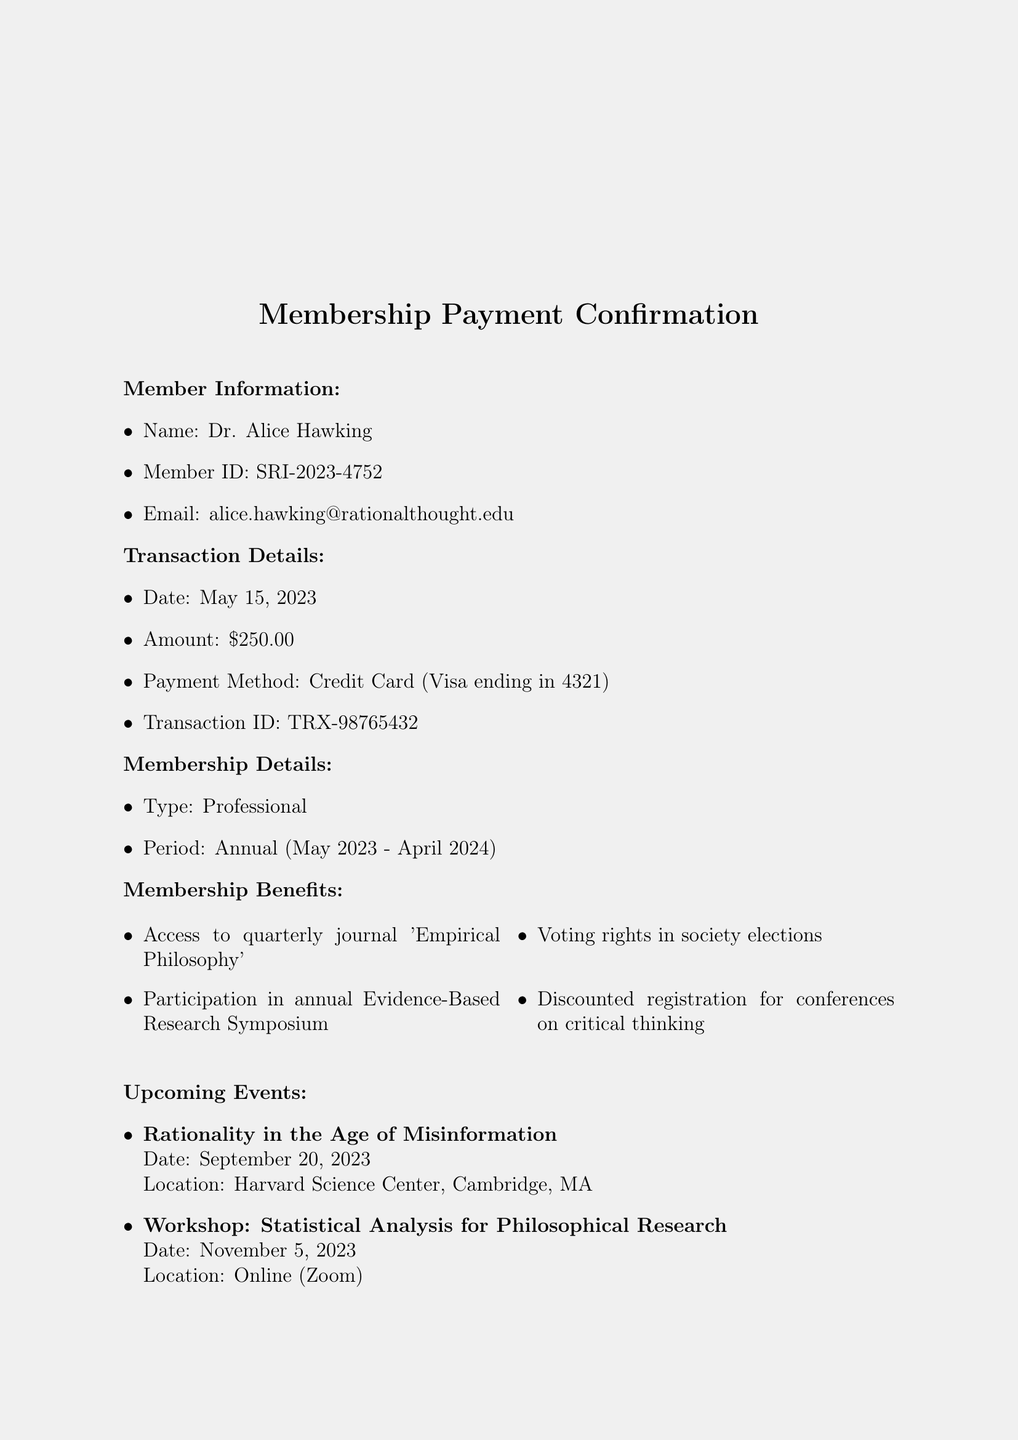What is the name of the organization? The organization is named "The Society for Rational Inquiry."
Answer: The Society for Rational Inquiry Who is the member? The member is identified as Dr. Alice Hawking in the document.
Answer: Dr. Alice Hawking What is the transaction date? The transaction date is provided as May 15, 2023.
Answer: May 15, 2023 What is the amount paid for the membership? The document states the amount paid as $250.00.
Answer: $250.00 What are the voting rights in society elections? The membership benefits include "Voting rights in society elections."
Answer: Voting rights in society elections What is the period of the membership? The membership period is listed as Annual (May 2023 - April 2024).
Answer: Annual (May 2023 - April 2024) Is the membership fee tax-deductible? The document confirms that the membership fee is tax-deductible to the extent allowed by law.
Answer: Yes Who is the contact person for membership inquiries? The contact person is Dr. Samuel Hitchens, as noted in the document.
Answer: Dr. Samuel Hitchens What event occurs on November 5, 2023? The upcoming event on November 5, 2023, is described as a "Workshop: Statistical Analysis for Philosophical Research."
Answer: Workshop: Statistical Analysis for Philosophical Research 